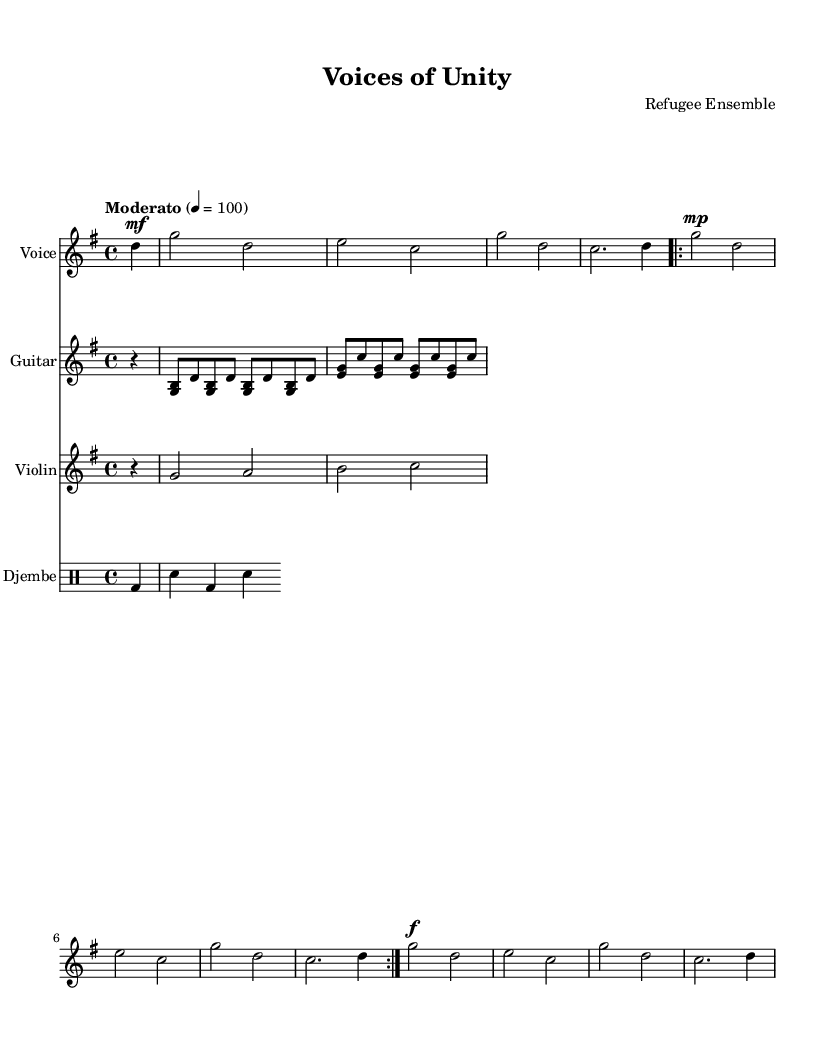What is the key signature of this music? The key signature appears at the beginning of the staff, indicating G major, which has one sharp (F#).
Answer: G major What is the time signature of this music? The time signature is found at the beginning of the staff and is displayed as 4/4, meaning there are four beats per measure.
Answer: 4/4 What is the tempo marking of this piece? The tempo marking indicates the speed of the piece, which is set to "Moderato" at 100 beats per minute.
Answer: Moderato How many measures are in the chorus? To find the number of measures, count the distinct musical segments labeled "Chorus." The chorus comprises 4 measures as indicated.
Answer: 4 What instruments are included in the score? By reviewing the individual staff labels, the instruments present are Voice, Guitar, Violin, and Djembe.
Answer: Voice, Guitar, Violin, Djembe How do the dynamics change in the chorus compared to the verse? The dynamics in the verse are marked "mp" (mezzo-piano) indicating a softer volume, while the chorus is marked "f" (forte) for a louder sound.
Answer: Softer to louder What is the title of this piece? The title is displayed prominently at the top of the sheet music, indicating its identity.
Answer: Voices of Unity 